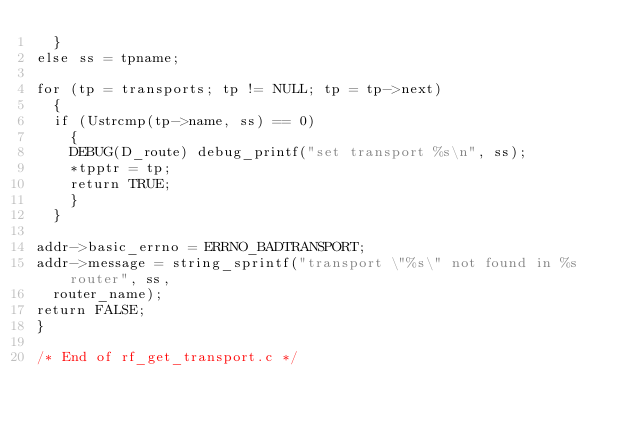Convert code to text. <code><loc_0><loc_0><loc_500><loc_500><_C_>  }
else ss = tpname;

for (tp = transports; tp != NULL; tp = tp->next)
  {
  if (Ustrcmp(tp->name, ss) == 0)
    {
    DEBUG(D_route) debug_printf("set transport %s\n", ss);
    *tpptr = tp;
    return TRUE;
    }
  }

addr->basic_errno = ERRNO_BADTRANSPORT;
addr->message = string_sprintf("transport \"%s\" not found in %s router", ss,
  router_name);
return FALSE;
}

/* End of rf_get_transport.c */
</code> 